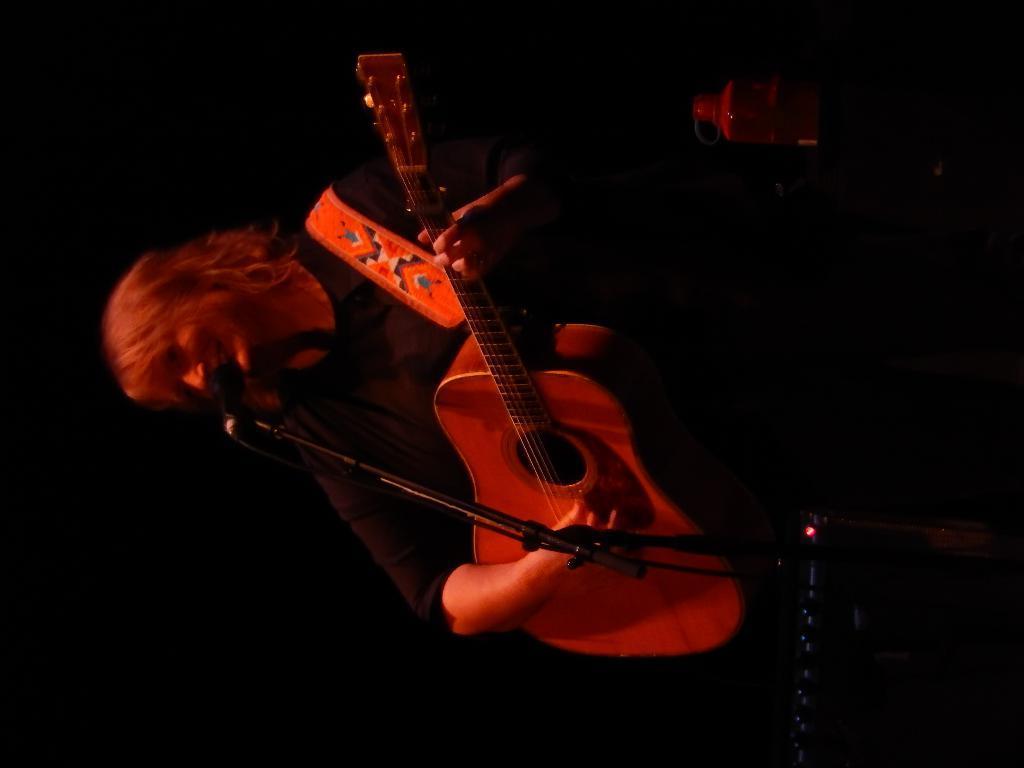In one or two sentences, can you explain what this image depicts? In this image we can see a person standing and holding a guitar in his hand. In the background we can see a bottle and a microphone in front of him. 